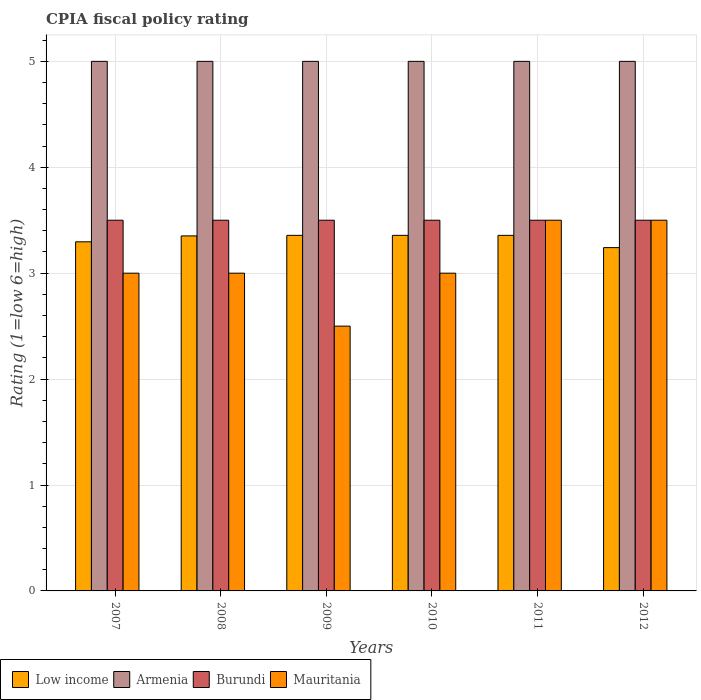How many different coloured bars are there?
Your answer should be very brief. 4. Are the number of bars on each tick of the X-axis equal?
Offer a terse response. Yes. How many bars are there on the 3rd tick from the left?
Offer a very short reply. 4. What is the label of the 2nd group of bars from the left?
Your answer should be compact. 2008. Across all years, what is the maximum CPIA rating in Low income?
Offer a very short reply. 3.36. Across all years, what is the minimum CPIA rating in Mauritania?
Your answer should be very brief. 2.5. In which year was the CPIA rating in Low income maximum?
Give a very brief answer. 2009. In which year was the CPIA rating in Burundi minimum?
Provide a succinct answer. 2007. What is the difference between the CPIA rating in Armenia in 2008 and the CPIA rating in Low income in 2009?
Provide a short and direct response. 1.64. What is the average CPIA rating in Armenia per year?
Provide a succinct answer. 5. In the year 2009, what is the difference between the CPIA rating in Burundi and CPIA rating in Low income?
Ensure brevity in your answer.  0.14. Is the CPIA rating in Armenia in 2010 less than that in 2011?
Keep it short and to the point. No. What is the difference between the highest and the second highest CPIA rating in Burundi?
Offer a very short reply. 0. What is the difference between the highest and the lowest CPIA rating in Low income?
Offer a very short reply. 0.12. In how many years, is the CPIA rating in Low income greater than the average CPIA rating in Low income taken over all years?
Ensure brevity in your answer.  4. Is the sum of the CPIA rating in Mauritania in 2008 and 2011 greater than the maximum CPIA rating in Low income across all years?
Give a very brief answer. Yes. What does the 4th bar from the left in 2012 represents?
Your answer should be very brief. Mauritania. What does the 1st bar from the right in 2011 represents?
Give a very brief answer. Mauritania. Is it the case that in every year, the sum of the CPIA rating in Low income and CPIA rating in Burundi is greater than the CPIA rating in Mauritania?
Provide a short and direct response. Yes. How many bars are there?
Give a very brief answer. 24. What is the difference between two consecutive major ticks on the Y-axis?
Your response must be concise. 1. Does the graph contain any zero values?
Your response must be concise. No. Does the graph contain grids?
Provide a short and direct response. Yes. How many legend labels are there?
Make the answer very short. 4. How are the legend labels stacked?
Keep it short and to the point. Horizontal. What is the title of the graph?
Ensure brevity in your answer.  CPIA fiscal policy rating. Does "Algeria" appear as one of the legend labels in the graph?
Offer a terse response. No. What is the label or title of the X-axis?
Provide a succinct answer. Years. What is the label or title of the Y-axis?
Ensure brevity in your answer.  Rating (1=low 6=high). What is the Rating (1=low 6=high) in Low income in 2007?
Your answer should be very brief. 3.3. What is the Rating (1=low 6=high) of Armenia in 2007?
Offer a very short reply. 5. What is the Rating (1=low 6=high) of Burundi in 2007?
Offer a very short reply. 3.5. What is the Rating (1=low 6=high) in Low income in 2008?
Your answer should be compact. 3.35. What is the Rating (1=low 6=high) in Burundi in 2008?
Your answer should be very brief. 3.5. What is the Rating (1=low 6=high) of Mauritania in 2008?
Offer a very short reply. 3. What is the Rating (1=low 6=high) in Low income in 2009?
Offer a very short reply. 3.36. What is the Rating (1=low 6=high) in Burundi in 2009?
Ensure brevity in your answer.  3.5. What is the Rating (1=low 6=high) of Low income in 2010?
Offer a very short reply. 3.36. What is the Rating (1=low 6=high) of Burundi in 2010?
Offer a very short reply. 3.5. What is the Rating (1=low 6=high) of Mauritania in 2010?
Keep it short and to the point. 3. What is the Rating (1=low 6=high) of Low income in 2011?
Your response must be concise. 3.36. What is the Rating (1=low 6=high) in Armenia in 2011?
Keep it short and to the point. 5. What is the Rating (1=low 6=high) of Burundi in 2011?
Offer a terse response. 3.5. What is the Rating (1=low 6=high) in Mauritania in 2011?
Give a very brief answer. 3.5. What is the Rating (1=low 6=high) in Low income in 2012?
Ensure brevity in your answer.  3.24. What is the Rating (1=low 6=high) of Burundi in 2012?
Offer a very short reply. 3.5. Across all years, what is the maximum Rating (1=low 6=high) of Low income?
Ensure brevity in your answer.  3.36. Across all years, what is the maximum Rating (1=low 6=high) of Armenia?
Your response must be concise. 5. Across all years, what is the minimum Rating (1=low 6=high) of Low income?
Your response must be concise. 3.24. What is the total Rating (1=low 6=high) in Low income in the graph?
Ensure brevity in your answer.  19.96. What is the total Rating (1=low 6=high) of Burundi in the graph?
Give a very brief answer. 21. What is the total Rating (1=low 6=high) in Mauritania in the graph?
Ensure brevity in your answer.  18.5. What is the difference between the Rating (1=low 6=high) in Low income in 2007 and that in 2008?
Your response must be concise. -0.06. What is the difference between the Rating (1=low 6=high) of Armenia in 2007 and that in 2008?
Make the answer very short. 0. What is the difference between the Rating (1=low 6=high) in Burundi in 2007 and that in 2008?
Your response must be concise. 0. What is the difference between the Rating (1=low 6=high) in Mauritania in 2007 and that in 2008?
Provide a succinct answer. 0. What is the difference between the Rating (1=low 6=high) of Low income in 2007 and that in 2009?
Offer a very short reply. -0.06. What is the difference between the Rating (1=low 6=high) of Armenia in 2007 and that in 2009?
Keep it short and to the point. 0. What is the difference between the Rating (1=low 6=high) in Low income in 2007 and that in 2010?
Make the answer very short. -0.06. What is the difference between the Rating (1=low 6=high) of Armenia in 2007 and that in 2010?
Give a very brief answer. 0. What is the difference between the Rating (1=low 6=high) in Low income in 2007 and that in 2011?
Your answer should be very brief. -0.06. What is the difference between the Rating (1=low 6=high) of Mauritania in 2007 and that in 2011?
Ensure brevity in your answer.  -0.5. What is the difference between the Rating (1=low 6=high) of Low income in 2007 and that in 2012?
Make the answer very short. 0.05. What is the difference between the Rating (1=low 6=high) in Armenia in 2007 and that in 2012?
Keep it short and to the point. 0. What is the difference between the Rating (1=low 6=high) of Mauritania in 2007 and that in 2012?
Provide a succinct answer. -0.5. What is the difference between the Rating (1=low 6=high) of Low income in 2008 and that in 2009?
Provide a succinct answer. -0.01. What is the difference between the Rating (1=low 6=high) of Low income in 2008 and that in 2010?
Offer a terse response. -0.01. What is the difference between the Rating (1=low 6=high) of Burundi in 2008 and that in 2010?
Your response must be concise. 0. What is the difference between the Rating (1=low 6=high) in Low income in 2008 and that in 2011?
Make the answer very short. -0.01. What is the difference between the Rating (1=low 6=high) of Burundi in 2008 and that in 2011?
Provide a short and direct response. 0. What is the difference between the Rating (1=low 6=high) in Mauritania in 2008 and that in 2011?
Your answer should be compact. -0.5. What is the difference between the Rating (1=low 6=high) in Low income in 2008 and that in 2012?
Offer a terse response. 0.11. What is the difference between the Rating (1=low 6=high) in Armenia in 2008 and that in 2012?
Your answer should be very brief. 0. What is the difference between the Rating (1=low 6=high) in Low income in 2009 and that in 2010?
Provide a short and direct response. 0. What is the difference between the Rating (1=low 6=high) in Burundi in 2009 and that in 2010?
Your answer should be compact. 0. What is the difference between the Rating (1=low 6=high) of Armenia in 2009 and that in 2011?
Keep it short and to the point. 0. What is the difference between the Rating (1=low 6=high) in Mauritania in 2009 and that in 2011?
Offer a very short reply. -1. What is the difference between the Rating (1=low 6=high) of Low income in 2009 and that in 2012?
Offer a terse response. 0.12. What is the difference between the Rating (1=low 6=high) in Burundi in 2009 and that in 2012?
Offer a very short reply. 0. What is the difference between the Rating (1=low 6=high) of Mauritania in 2009 and that in 2012?
Your response must be concise. -1. What is the difference between the Rating (1=low 6=high) of Low income in 2010 and that in 2011?
Make the answer very short. 0. What is the difference between the Rating (1=low 6=high) of Mauritania in 2010 and that in 2011?
Keep it short and to the point. -0.5. What is the difference between the Rating (1=low 6=high) of Low income in 2010 and that in 2012?
Your response must be concise. 0.12. What is the difference between the Rating (1=low 6=high) in Burundi in 2010 and that in 2012?
Give a very brief answer. 0. What is the difference between the Rating (1=low 6=high) of Low income in 2011 and that in 2012?
Your response must be concise. 0.12. What is the difference between the Rating (1=low 6=high) of Armenia in 2011 and that in 2012?
Provide a short and direct response. 0. What is the difference between the Rating (1=low 6=high) in Burundi in 2011 and that in 2012?
Make the answer very short. 0. What is the difference between the Rating (1=low 6=high) of Mauritania in 2011 and that in 2012?
Offer a very short reply. 0. What is the difference between the Rating (1=low 6=high) of Low income in 2007 and the Rating (1=low 6=high) of Armenia in 2008?
Offer a very short reply. -1.7. What is the difference between the Rating (1=low 6=high) in Low income in 2007 and the Rating (1=low 6=high) in Burundi in 2008?
Your answer should be compact. -0.2. What is the difference between the Rating (1=low 6=high) of Low income in 2007 and the Rating (1=low 6=high) of Mauritania in 2008?
Provide a succinct answer. 0.3. What is the difference between the Rating (1=low 6=high) in Armenia in 2007 and the Rating (1=low 6=high) in Mauritania in 2008?
Offer a very short reply. 2. What is the difference between the Rating (1=low 6=high) in Low income in 2007 and the Rating (1=low 6=high) in Armenia in 2009?
Offer a very short reply. -1.7. What is the difference between the Rating (1=low 6=high) in Low income in 2007 and the Rating (1=low 6=high) in Burundi in 2009?
Your answer should be compact. -0.2. What is the difference between the Rating (1=low 6=high) in Low income in 2007 and the Rating (1=low 6=high) in Mauritania in 2009?
Provide a succinct answer. 0.8. What is the difference between the Rating (1=low 6=high) of Armenia in 2007 and the Rating (1=low 6=high) of Burundi in 2009?
Your response must be concise. 1.5. What is the difference between the Rating (1=low 6=high) in Armenia in 2007 and the Rating (1=low 6=high) in Mauritania in 2009?
Provide a short and direct response. 2.5. What is the difference between the Rating (1=low 6=high) of Low income in 2007 and the Rating (1=low 6=high) of Armenia in 2010?
Offer a terse response. -1.7. What is the difference between the Rating (1=low 6=high) of Low income in 2007 and the Rating (1=low 6=high) of Burundi in 2010?
Your response must be concise. -0.2. What is the difference between the Rating (1=low 6=high) in Low income in 2007 and the Rating (1=low 6=high) in Mauritania in 2010?
Keep it short and to the point. 0.3. What is the difference between the Rating (1=low 6=high) of Armenia in 2007 and the Rating (1=low 6=high) of Burundi in 2010?
Your answer should be compact. 1.5. What is the difference between the Rating (1=low 6=high) of Armenia in 2007 and the Rating (1=low 6=high) of Mauritania in 2010?
Keep it short and to the point. 2. What is the difference between the Rating (1=low 6=high) of Low income in 2007 and the Rating (1=low 6=high) of Armenia in 2011?
Your answer should be compact. -1.7. What is the difference between the Rating (1=low 6=high) in Low income in 2007 and the Rating (1=low 6=high) in Burundi in 2011?
Your answer should be very brief. -0.2. What is the difference between the Rating (1=low 6=high) in Low income in 2007 and the Rating (1=low 6=high) in Mauritania in 2011?
Provide a short and direct response. -0.2. What is the difference between the Rating (1=low 6=high) of Armenia in 2007 and the Rating (1=low 6=high) of Burundi in 2011?
Provide a short and direct response. 1.5. What is the difference between the Rating (1=low 6=high) in Armenia in 2007 and the Rating (1=low 6=high) in Mauritania in 2011?
Offer a terse response. 1.5. What is the difference between the Rating (1=low 6=high) in Burundi in 2007 and the Rating (1=low 6=high) in Mauritania in 2011?
Your response must be concise. 0. What is the difference between the Rating (1=low 6=high) of Low income in 2007 and the Rating (1=low 6=high) of Armenia in 2012?
Your response must be concise. -1.7. What is the difference between the Rating (1=low 6=high) of Low income in 2007 and the Rating (1=low 6=high) of Burundi in 2012?
Make the answer very short. -0.2. What is the difference between the Rating (1=low 6=high) of Low income in 2007 and the Rating (1=low 6=high) of Mauritania in 2012?
Your response must be concise. -0.2. What is the difference between the Rating (1=low 6=high) of Armenia in 2007 and the Rating (1=low 6=high) of Mauritania in 2012?
Keep it short and to the point. 1.5. What is the difference between the Rating (1=low 6=high) of Burundi in 2007 and the Rating (1=low 6=high) of Mauritania in 2012?
Your response must be concise. 0. What is the difference between the Rating (1=low 6=high) of Low income in 2008 and the Rating (1=low 6=high) of Armenia in 2009?
Ensure brevity in your answer.  -1.65. What is the difference between the Rating (1=low 6=high) of Low income in 2008 and the Rating (1=low 6=high) of Burundi in 2009?
Give a very brief answer. -0.15. What is the difference between the Rating (1=low 6=high) of Low income in 2008 and the Rating (1=low 6=high) of Mauritania in 2009?
Your response must be concise. 0.85. What is the difference between the Rating (1=low 6=high) in Armenia in 2008 and the Rating (1=low 6=high) in Burundi in 2009?
Give a very brief answer. 1.5. What is the difference between the Rating (1=low 6=high) of Armenia in 2008 and the Rating (1=low 6=high) of Mauritania in 2009?
Your answer should be compact. 2.5. What is the difference between the Rating (1=low 6=high) of Burundi in 2008 and the Rating (1=low 6=high) of Mauritania in 2009?
Give a very brief answer. 1. What is the difference between the Rating (1=low 6=high) of Low income in 2008 and the Rating (1=low 6=high) of Armenia in 2010?
Give a very brief answer. -1.65. What is the difference between the Rating (1=low 6=high) in Low income in 2008 and the Rating (1=low 6=high) in Burundi in 2010?
Give a very brief answer. -0.15. What is the difference between the Rating (1=low 6=high) of Low income in 2008 and the Rating (1=low 6=high) of Mauritania in 2010?
Offer a very short reply. 0.35. What is the difference between the Rating (1=low 6=high) in Armenia in 2008 and the Rating (1=low 6=high) in Mauritania in 2010?
Offer a very short reply. 2. What is the difference between the Rating (1=low 6=high) in Burundi in 2008 and the Rating (1=low 6=high) in Mauritania in 2010?
Provide a short and direct response. 0.5. What is the difference between the Rating (1=low 6=high) in Low income in 2008 and the Rating (1=low 6=high) in Armenia in 2011?
Your answer should be very brief. -1.65. What is the difference between the Rating (1=low 6=high) in Low income in 2008 and the Rating (1=low 6=high) in Burundi in 2011?
Offer a terse response. -0.15. What is the difference between the Rating (1=low 6=high) of Low income in 2008 and the Rating (1=low 6=high) of Mauritania in 2011?
Give a very brief answer. -0.15. What is the difference between the Rating (1=low 6=high) in Armenia in 2008 and the Rating (1=low 6=high) in Burundi in 2011?
Provide a short and direct response. 1.5. What is the difference between the Rating (1=low 6=high) of Burundi in 2008 and the Rating (1=low 6=high) of Mauritania in 2011?
Give a very brief answer. 0. What is the difference between the Rating (1=low 6=high) in Low income in 2008 and the Rating (1=low 6=high) in Armenia in 2012?
Keep it short and to the point. -1.65. What is the difference between the Rating (1=low 6=high) in Low income in 2008 and the Rating (1=low 6=high) in Burundi in 2012?
Keep it short and to the point. -0.15. What is the difference between the Rating (1=low 6=high) of Low income in 2008 and the Rating (1=low 6=high) of Mauritania in 2012?
Your response must be concise. -0.15. What is the difference between the Rating (1=low 6=high) in Armenia in 2008 and the Rating (1=low 6=high) in Burundi in 2012?
Offer a very short reply. 1.5. What is the difference between the Rating (1=low 6=high) in Armenia in 2008 and the Rating (1=low 6=high) in Mauritania in 2012?
Your answer should be very brief. 1.5. What is the difference between the Rating (1=low 6=high) of Burundi in 2008 and the Rating (1=low 6=high) of Mauritania in 2012?
Give a very brief answer. 0. What is the difference between the Rating (1=low 6=high) in Low income in 2009 and the Rating (1=low 6=high) in Armenia in 2010?
Offer a terse response. -1.64. What is the difference between the Rating (1=low 6=high) of Low income in 2009 and the Rating (1=low 6=high) of Burundi in 2010?
Provide a short and direct response. -0.14. What is the difference between the Rating (1=low 6=high) of Low income in 2009 and the Rating (1=low 6=high) of Mauritania in 2010?
Provide a short and direct response. 0.36. What is the difference between the Rating (1=low 6=high) of Armenia in 2009 and the Rating (1=low 6=high) of Mauritania in 2010?
Your response must be concise. 2. What is the difference between the Rating (1=low 6=high) of Burundi in 2009 and the Rating (1=low 6=high) of Mauritania in 2010?
Offer a very short reply. 0.5. What is the difference between the Rating (1=low 6=high) of Low income in 2009 and the Rating (1=low 6=high) of Armenia in 2011?
Your answer should be very brief. -1.64. What is the difference between the Rating (1=low 6=high) in Low income in 2009 and the Rating (1=low 6=high) in Burundi in 2011?
Make the answer very short. -0.14. What is the difference between the Rating (1=low 6=high) in Low income in 2009 and the Rating (1=low 6=high) in Mauritania in 2011?
Provide a short and direct response. -0.14. What is the difference between the Rating (1=low 6=high) in Low income in 2009 and the Rating (1=low 6=high) in Armenia in 2012?
Your answer should be very brief. -1.64. What is the difference between the Rating (1=low 6=high) of Low income in 2009 and the Rating (1=low 6=high) of Burundi in 2012?
Provide a succinct answer. -0.14. What is the difference between the Rating (1=low 6=high) of Low income in 2009 and the Rating (1=low 6=high) of Mauritania in 2012?
Offer a terse response. -0.14. What is the difference between the Rating (1=low 6=high) in Armenia in 2009 and the Rating (1=low 6=high) in Burundi in 2012?
Provide a short and direct response. 1.5. What is the difference between the Rating (1=low 6=high) in Burundi in 2009 and the Rating (1=low 6=high) in Mauritania in 2012?
Provide a succinct answer. 0. What is the difference between the Rating (1=low 6=high) in Low income in 2010 and the Rating (1=low 6=high) in Armenia in 2011?
Make the answer very short. -1.64. What is the difference between the Rating (1=low 6=high) in Low income in 2010 and the Rating (1=low 6=high) in Burundi in 2011?
Offer a very short reply. -0.14. What is the difference between the Rating (1=low 6=high) of Low income in 2010 and the Rating (1=low 6=high) of Mauritania in 2011?
Your answer should be very brief. -0.14. What is the difference between the Rating (1=low 6=high) in Armenia in 2010 and the Rating (1=low 6=high) in Mauritania in 2011?
Make the answer very short. 1.5. What is the difference between the Rating (1=low 6=high) of Burundi in 2010 and the Rating (1=low 6=high) of Mauritania in 2011?
Keep it short and to the point. 0. What is the difference between the Rating (1=low 6=high) in Low income in 2010 and the Rating (1=low 6=high) in Armenia in 2012?
Offer a terse response. -1.64. What is the difference between the Rating (1=low 6=high) in Low income in 2010 and the Rating (1=low 6=high) in Burundi in 2012?
Ensure brevity in your answer.  -0.14. What is the difference between the Rating (1=low 6=high) of Low income in 2010 and the Rating (1=low 6=high) of Mauritania in 2012?
Give a very brief answer. -0.14. What is the difference between the Rating (1=low 6=high) in Burundi in 2010 and the Rating (1=low 6=high) in Mauritania in 2012?
Offer a very short reply. 0. What is the difference between the Rating (1=low 6=high) in Low income in 2011 and the Rating (1=low 6=high) in Armenia in 2012?
Your answer should be very brief. -1.64. What is the difference between the Rating (1=low 6=high) in Low income in 2011 and the Rating (1=low 6=high) in Burundi in 2012?
Make the answer very short. -0.14. What is the difference between the Rating (1=low 6=high) of Low income in 2011 and the Rating (1=low 6=high) of Mauritania in 2012?
Give a very brief answer. -0.14. What is the difference between the Rating (1=low 6=high) of Armenia in 2011 and the Rating (1=low 6=high) of Mauritania in 2012?
Offer a very short reply. 1.5. What is the difference between the Rating (1=low 6=high) in Burundi in 2011 and the Rating (1=low 6=high) in Mauritania in 2012?
Make the answer very short. 0. What is the average Rating (1=low 6=high) of Low income per year?
Your answer should be compact. 3.33. What is the average Rating (1=low 6=high) of Armenia per year?
Your answer should be very brief. 5. What is the average Rating (1=low 6=high) of Burundi per year?
Make the answer very short. 3.5. What is the average Rating (1=low 6=high) in Mauritania per year?
Provide a short and direct response. 3.08. In the year 2007, what is the difference between the Rating (1=low 6=high) of Low income and Rating (1=low 6=high) of Armenia?
Your answer should be compact. -1.7. In the year 2007, what is the difference between the Rating (1=low 6=high) of Low income and Rating (1=low 6=high) of Burundi?
Make the answer very short. -0.2. In the year 2007, what is the difference between the Rating (1=low 6=high) in Low income and Rating (1=low 6=high) in Mauritania?
Provide a succinct answer. 0.3. In the year 2007, what is the difference between the Rating (1=low 6=high) of Armenia and Rating (1=low 6=high) of Burundi?
Your answer should be very brief. 1.5. In the year 2007, what is the difference between the Rating (1=low 6=high) of Armenia and Rating (1=low 6=high) of Mauritania?
Offer a terse response. 2. In the year 2007, what is the difference between the Rating (1=low 6=high) of Burundi and Rating (1=low 6=high) of Mauritania?
Give a very brief answer. 0.5. In the year 2008, what is the difference between the Rating (1=low 6=high) of Low income and Rating (1=low 6=high) of Armenia?
Give a very brief answer. -1.65. In the year 2008, what is the difference between the Rating (1=low 6=high) in Low income and Rating (1=low 6=high) in Burundi?
Ensure brevity in your answer.  -0.15. In the year 2008, what is the difference between the Rating (1=low 6=high) in Low income and Rating (1=low 6=high) in Mauritania?
Provide a succinct answer. 0.35. In the year 2008, what is the difference between the Rating (1=low 6=high) in Armenia and Rating (1=low 6=high) in Burundi?
Keep it short and to the point. 1.5. In the year 2009, what is the difference between the Rating (1=low 6=high) of Low income and Rating (1=low 6=high) of Armenia?
Your answer should be very brief. -1.64. In the year 2009, what is the difference between the Rating (1=low 6=high) in Low income and Rating (1=low 6=high) in Burundi?
Provide a short and direct response. -0.14. In the year 2009, what is the difference between the Rating (1=low 6=high) in Low income and Rating (1=low 6=high) in Mauritania?
Provide a short and direct response. 0.86. In the year 2009, what is the difference between the Rating (1=low 6=high) of Armenia and Rating (1=low 6=high) of Mauritania?
Your answer should be compact. 2.5. In the year 2010, what is the difference between the Rating (1=low 6=high) in Low income and Rating (1=low 6=high) in Armenia?
Offer a very short reply. -1.64. In the year 2010, what is the difference between the Rating (1=low 6=high) in Low income and Rating (1=low 6=high) in Burundi?
Offer a terse response. -0.14. In the year 2010, what is the difference between the Rating (1=low 6=high) of Low income and Rating (1=low 6=high) of Mauritania?
Your answer should be compact. 0.36. In the year 2010, what is the difference between the Rating (1=low 6=high) in Burundi and Rating (1=low 6=high) in Mauritania?
Provide a succinct answer. 0.5. In the year 2011, what is the difference between the Rating (1=low 6=high) in Low income and Rating (1=low 6=high) in Armenia?
Your response must be concise. -1.64. In the year 2011, what is the difference between the Rating (1=low 6=high) in Low income and Rating (1=low 6=high) in Burundi?
Ensure brevity in your answer.  -0.14. In the year 2011, what is the difference between the Rating (1=low 6=high) in Low income and Rating (1=low 6=high) in Mauritania?
Your answer should be compact. -0.14. In the year 2011, what is the difference between the Rating (1=low 6=high) in Armenia and Rating (1=low 6=high) in Burundi?
Ensure brevity in your answer.  1.5. In the year 2012, what is the difference between the Rating (1=low 6=high) of Low income and Rating (1=low 6=high) of Armenia?
Make the answer very short. -1.76. In the year 2012, what is the difference between the Rating (1=low 6=high) in Low income and Rating (1=low 6=high) in Burundi?
Your answer should be very brief. -0.26. In the year 2012, what is the difference between the Rating (1=low 6=high) of Low income and Rating (1=low 6=high) of Mauritania?
Keep it short and to the point. -0.26. In the year 2012, what is the difference between the Rating (1=low 6=high) of Armenia and Rating (1=low 6=high) of Mauritania?
Make the answer very short. 1.5. What is the ratio of the Rating (1=low 6=high) in Low income in 2007 to that in 2008?
Offer a very short reply. 0.98. What is the ratio of the Rating (1=low 6=high) in Mauritania in 2007 to that in 2008?
Make the answer very short. 1. What is the ratio of the Rating (1=low 6=high) in Low income in 2007 to that in 2009?
Ensure brevity in your answer.  0.98. What is the ratio of the Rating (1=low 6=high) in Burundi in 2007 to that in 2009?
Provide a short and direct response. 1. What is the ratio of the Rating (1=low 6=high) of Low income in 2007 to that in 2010?
Keep it short and to the point. 0.98. What is the ratio of the Rating (1=low 6=high) of Burundi in 2007 to that in 2010?
Your answer should be very brief. 1. What is the ratio of the Rating (1=low 6=high) of Mauritania in 2007 to that in 2010?
Offer a terse response. 1. What is the ratio of the Rating (1=low 6=high) in Low income in 2007 to that in 2011?
Your answer should be compact. 0.98. What is the ratio of the Rating (1=low 6=high) of Armenia in 2007 to that in 2011?
Ensure brevity in your answer.  1. What is the ratio of the Rating (1=low 6=high) in Burundi in 2007 to that in 2011?
Offer a very short reply. 1. What is the ratio of the Rating (1=low 6=high) of Mauritania in 2007 to that in 2011?
Ensure brevity in your answer.  0.86. What is the ratio of the Rating (1=low 6=high) of Low income in 2007 to that in 2012?
Your response must be concise. 1.02. What is the ratio of the Rating (1=low 6=high) in Burundi in 2007 to that in 2012?
Offer a terse response. 1. What is the ratio of the Rating (1=low 6=high) of Armenia in 2008 to that in 2009?
Keep it short and to the point. 1. What is the ratio of the Rating (1=low 6=high) of Burundi in 2008 to that in 2009?
Your response must be concise. 1. What is the ratio of the Rating (1=low 6=high) in Burundi in 2008 to that in 2010?
Offer a terse response. 1. What is the ratio of the Rating (1=low 6=high) in Low income in 2008 to that in 2012?
Make the answer very short. 1.03. What is the ratio of the Rating (1=low 6=high) in Armenia in 2008 to that in 2012?
Keep it short and to the point. 1. What is the ratio of the Rating (1=low 6=high) of Burundi in 2008 to that in 2012?
Give a very brief answer. 1. What is the ratio of the Rating (1=low 6=high) in Low income in 2009 to that in 2010?
Your answer should be very brief. 1. What is the ratio of the Rating (1=low 6=high) of Burundi in 2009 to that in 2010?
Your response must be concise. 1. What is the ratio of the Rating (1=low 6=high) of Low income in 2009 to that in 2011?
Your answer should be very brief. 1. What is the ratio of the Rating (1=low 6=high) of Burundi in 2009 to that in 2011?
Your response must be concise. 1. What is the ratio of the Rating (1=low 6=high) of Low income in 2009 to that in 2012?
Ensure brevity in your answer.  1.04. What is the ratio of the Rating (1=low 6=high) of Armenia in 2009 to that in 2012?
Ensure brevity in your answer.  1. What is the ratio of the Rating (1=low 6=high) in Low income in 2010 to that in 2011?
Provide a short and direct response. 1. What is the ratio of the Rating (1=low 6=high) of Burundi in 2010 to that in 2011?
Ensure brevity in your answer.  1. What is the ratio of the Rating (1=low 6=high) of Mauritania in 2010 to that in 2011?
Your answer should be compact. 0.86. What is the ratio of the Rating (1=low 6=high) in Low income in 2010 to that in 2012?
Ensure brevity in your answer.  1.04. What is the ratio of the Rating (1=low 6=high) in Burundi in 2010 to that in 2012?
Offer a terse response. 1. What is the ratio of the Rating (1=low 6=high) of Mauritania in 2010 to that in 2012?
Provide a succinct answer. 0.86. What is the ratio of the Rating (1=low 6=high) of Low income in 2011 to that in 2012?
Ensure brevity in your answer.  1.04. What is the ratio of the Rating (1=low 6=high) of Armenia in 2011 to that in 2012?
Keep it short and to the point. 1. What is the ratio of the Rating (1=low 6=high) of Mauritania in 2011 to that in 2012?
Give a very brief answer. 1. What is the difference between the highest and the second highest Rating (1=low 6=high) of Low income?
Give a very brief answer. 0. What is the difference between the highest and the second highest Rating (1=low 6=high) of Armenia?
Ensure brevity in your answer.  0. What is the difference between the highest and the lowest Rating (1=low 6=high) in Low income?
Your answer should be very brief. 0.12. What is the difference between the highest and the lowest Rating (1=low 6=high) of Burundi?
Make the answer very short. 0. 